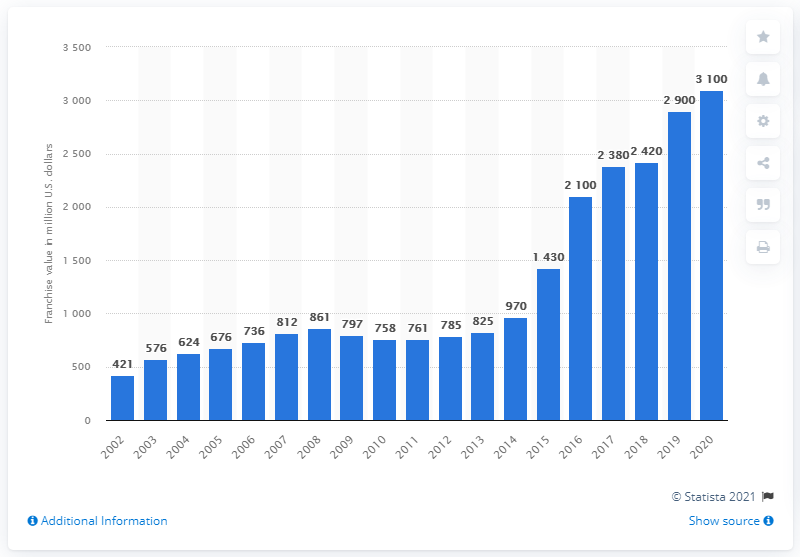Identify some key points in this picture. The value of the Las Vegas Raiders in 2020 was 3,100. 